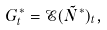Convert formula to latex. <formula><loc_0><loc_0><loc_500><loc_500>G ^ { * } _ { t } = \mathcal { E } ( \tilde { N } ^ { * } ) _ { t } ,</formula> 